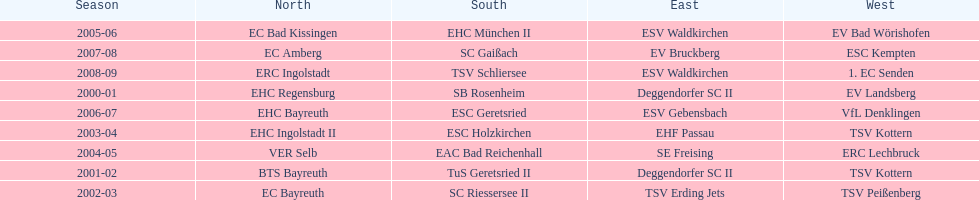Who won the south after esc geretsried did during the 2006-07 season? SC Gaißach. 